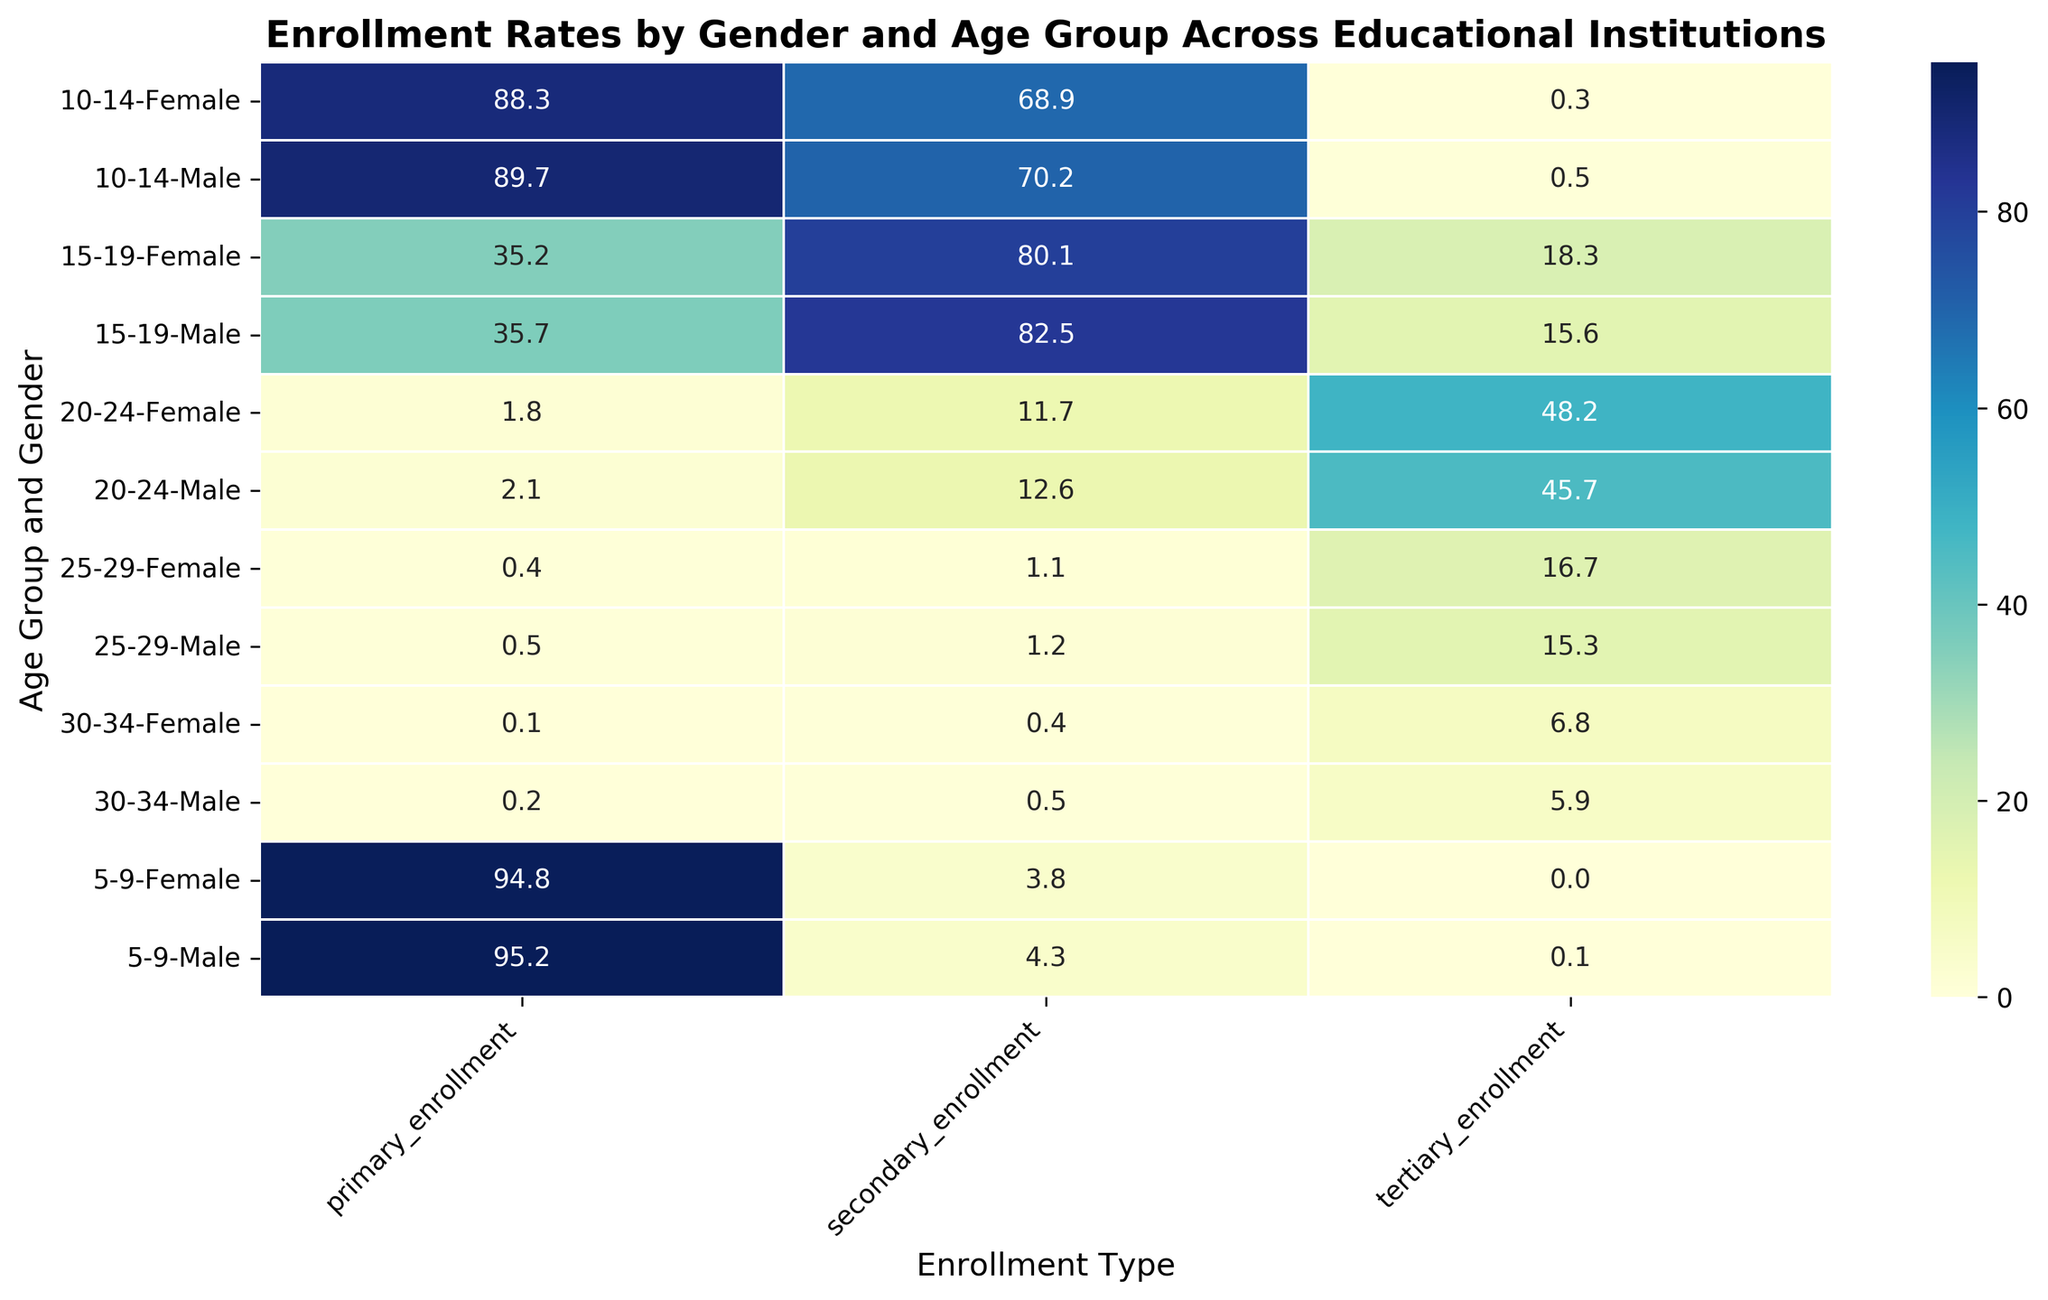What's the difference in primary enrollment rates between males aged 5-9 and females aged 5-9? To find the difference, look at the primary enrollment rates for males and females aged 5-9. The primary enrollment rate for males aged 5-9 is 95.2%, and for females aged 5-9, it is 94.8%. The difference is 95.2% - 94.8%.
Answer: 0.4% Which gender has a higher secondary enrollment rate in the 15-19 age group? Check the secondary enrollment rates for both males and females in the 15-19 age group. Males have a secondary enrollment rate of 82.5%, while females have a rate of 80.1%.
Answer: Male By how much does tertiary enrollment increase from the 20-24 age group to the 25-29 age group for females? Compare the tertiary enrollment rates for females in the 20-24 and 25-29 age groups. The rate for 20-24 is 48.2%, and for 25-29, it is 16.7%. The change is 16.7% - 48.2%.
Answer: -31.5% What is the sum of the secondary and tertiary enrollments for males aged 20-24? Add the secondary and tertiary enrollment rates for males aged 20-24. The secondary rate is 12.6%, and the tertiary rate is 45.7%. The sum is 12.6% + 45.7%.
Answer: 58.3% In which age group and gender is primary enrollment lowest? Find the lowest value in the primary enrollment column across all age groups and genders. The lowest primary enrollment rates are for males and females in the 30-34 age group, with values of 0.2% and 0.1%, respectively.
Answer: Female, 30-34 What's the average tertiary enrollment rate for both males and females in the 15-19 age group? Calculate the average of the tertiary enrollment rates for both genders in the 15-19 age group. For males, it is 15.6%, and for females, it is 18.3%. The average is (15.6% + 18.3%) / 2.
Answer: 16.95% Compare the secondary enrollment rates for males and females in the 10-14 age group. Which is higher, and by how much? Look at the secondary enrollment rates in the 10-14 age group; males have 70.2%, and females have 68.9%. The difference is 70.2% - 68.9%.
Answer: Males, 1.3% What is the trend in the primary enrollment rate as age increases for males? Observing the primary enrollment rates for males across different age groups, we see the rates decrease from 95.2% (5-9), to 89.7% (10-14), to 35.7% (15-19), and so on until it reaches 0.2% (30-34).
Answer: Decreasing By how much does the tertiary enrollment rate differ between males and females in the 25-29 age group? Compare the tertiary enrollment rates for males and females in the 25-29 age group. Males have 15.3%, and females have 16.7%. The difference is 16.7% - 15.3%.
Answer: 1.4% How does the color intensity change for tertiary enrollment rates in the 20-24 age group? Look at the color intensity for tertiary enrollment rates in the 20-24 age group. Males have a value of 45.7%, and females have 48.2%. Both have darker colors compared to younger age groups, indicating higher enrollment rates.
Answer: Darker 